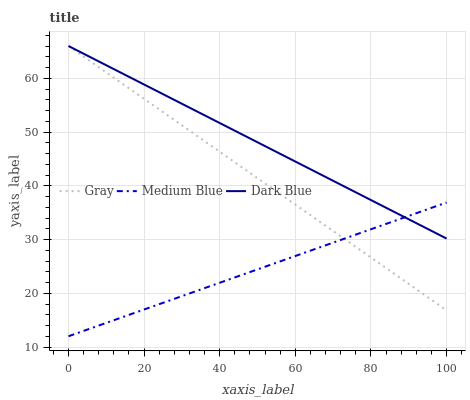Does Medium Blue have the minimum area under the curve?
Answer yes or no. Yes. Does Dark Blue have the maximum area under the curve?
Answer yes or no. Yes. Does Dark Blue have the minimum area under the curve?
Answer yes or no. No. Does Medium Blue have the maximum area under the curve?
Answer yes or no. No. Is Medium Blue the smoothest?
Answer yes or no. Yes. Is Gray the roughest?
Answer yes or no. Yes. Is Dark Blue the smoothest?
Answer yes or no. No. Is Dark Blue the roughest?
Answer yes or no. No. Does Medium Blue have the lowest value?
Answer yes or no. Yes. Does Dark Blue have the lowest value?
Answer yes or no. No. Does Dark Blue have the highest value?
Answer yes or no. Yes. Does Medium Blue have the highest value?
Answer yes or no. No. Does Gray intersect Medium Blue?
Answer yes or no. Yes. Is Gray less than Medium Blue?
Answer yes or no. No. Is Gray greater than Medium Blue?
Answer yes or no. No. 